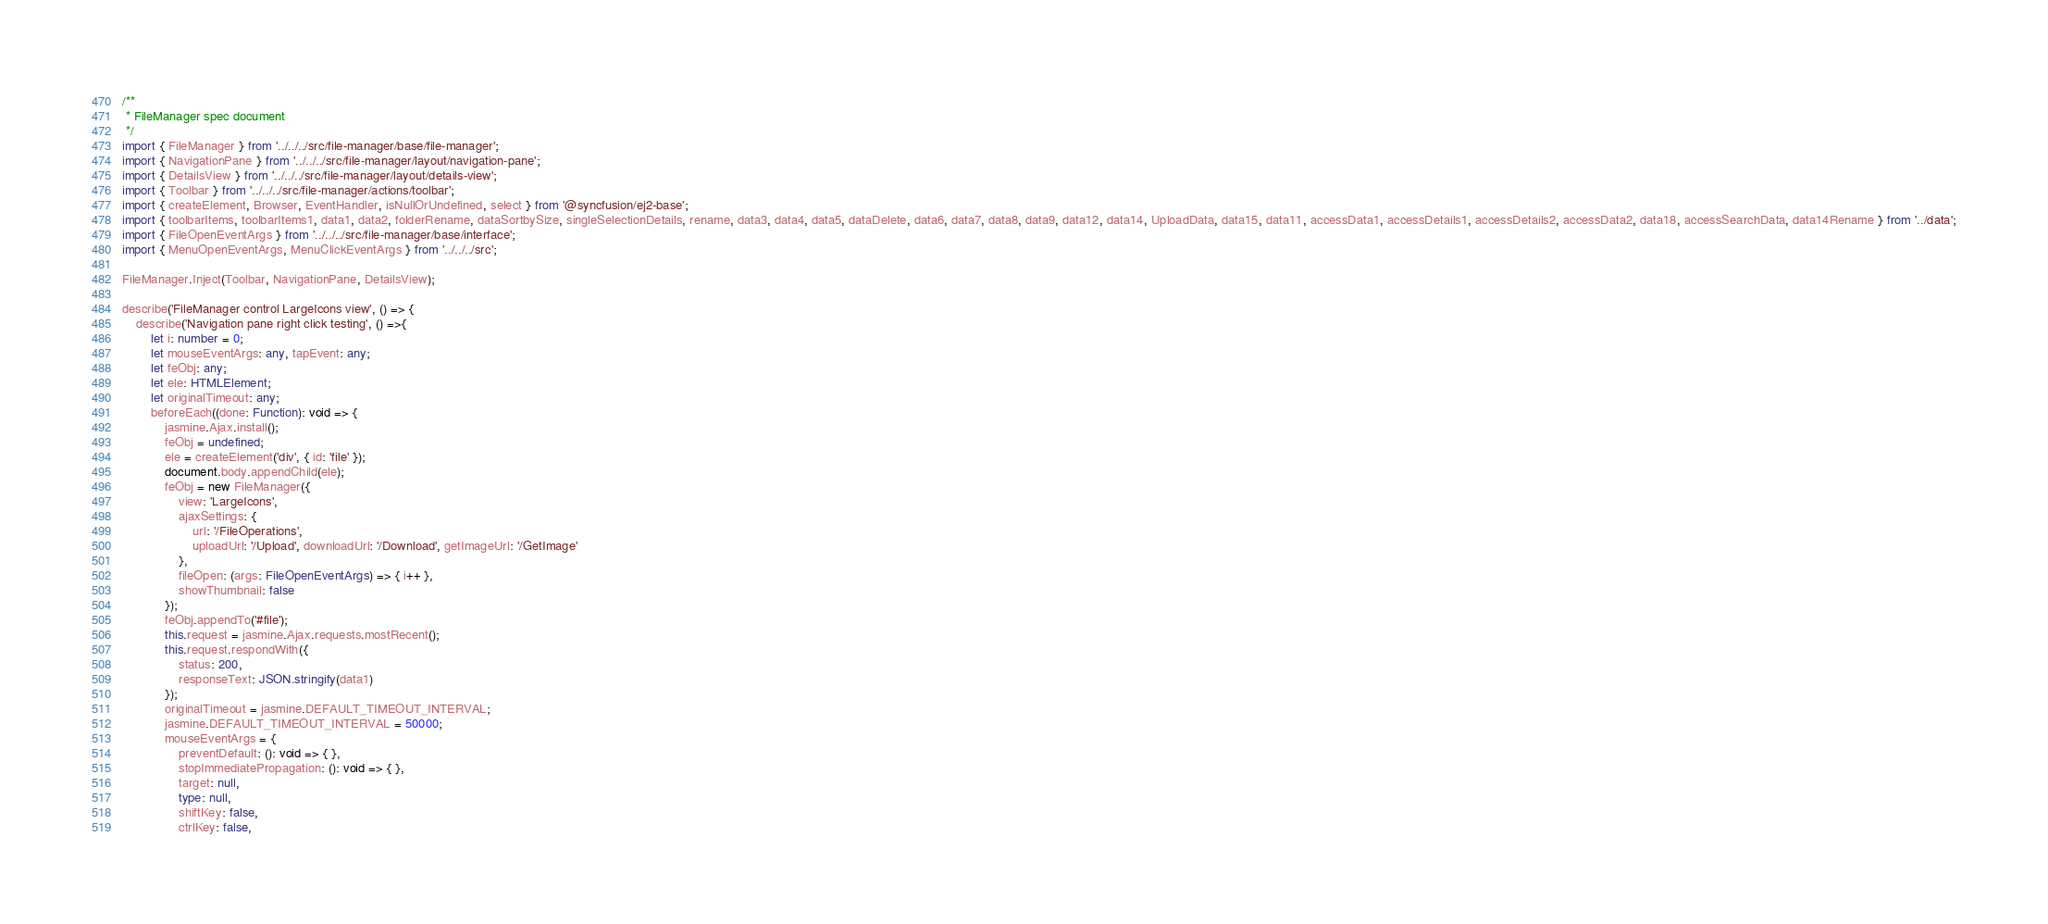<code> <loc_0><loc_0><loc_500><loc_500><_TypeScript_>/**
 * FileManager spec document
 */
import { FileManager } from '../../../src/file-manager/base/file-manager';
import { NavigationPane } from '../../../src/file-manager/layout/navigation-pane';
import { DetailsView } from '../../../src/file-manager/layout/details-view';
import { Toolbar } from '../../../src/file-manager/actions/toolbar';
import { createElement, Browser, EventHandler, isNullOrUndefined, select } from '@syncfusion/ej2-base';
import { toolbarItems, toolbarItems1, data1, data2, folderRename, dataSortbySize, singleSelectionDetails, rename, data3, data4, data5, dataDelete, data6, data7, data8, data9, data12, data14, UploadData, data15, data11, accessData1, accessDetails1, accessDetails2, accessData2, data18, accessSearchData, data14Rename } from '../data';
import { FileOpenEventArgs } from '../../../src/file-manager/base/interface';
import { MenuOpenEventArgs, MenuClickEventArgs } from '../../../src';

FileManager.Inject(Toolbar, NavigationPane, DetailsView);

describe('FileManager control LargeIcons view', () => {
    describe('Navigation pane right click testing', () =>{
        let i: number = 0;
        let mouseEventArgs: any, tapEvent: any;
        let feObj: any;
        let ele: HTMLElement;
        let originalTimeout: any;
        beforeEach((done: Function): void => {
            jasmine.Ajax.install();
            feObj = undefined;
            ele = createElement('div', { id: 'file' });
            document.body.appendChild(ele);
            feObj = new FileManager({
                view: 'LargeIcons',
                ajaxSettings: {
                    url: '/FileOperations',
                    uploadUrl: '/Upload', downloadUrl: '/Download', getImageUrl: '/GetImage'
                },
                fileOpen: (args: FileOpenEventArgs) => { i++ },
                showThumbnail: false
            });
            feObj.appendTo('#file');
            this.request = jasmine.Ajax.requests.mostRecent();
            this.request.respondWith({
                status: 200,
                responseText: JSON.stringify(data1)
            });
            originalTimeout = jasmine.DEFAULT_TIMEOUT_INTERVAL;
            jasmine.DEFAULT_TIMEOUT_INTERVAL = 50000;
            mouseEventArgs = {
                preventDefault: (): void => { },
                stopImmediatePropagation: (): void => { },
                target: null,
                type: null,
                shiftKey: false,
                ctrlKey: false,</code> 